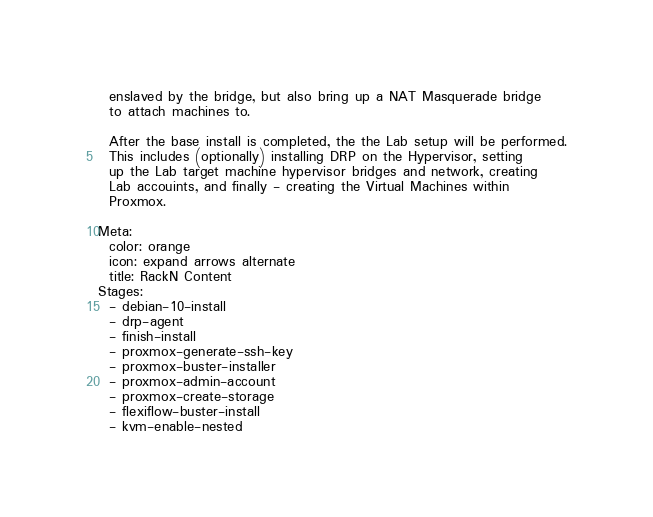<code> <loc_0><loc_0><loc_500><loc_500><_YAML_>  enslaved by the bridge, but also bring up a NAT Masquerade bridge
  to attach machines to.

  After the base install is completed, the the Lab setup will be performed.
  This includes (optionally) installing DRP on the Hypervisor, setting
  up the Lab target machine hypervisor bridges and network, creating
  Lab accouints, and finally - creating the Virtual Machines within
  Proxmox.

Meta:
  color: orange
  icon: expand arrows alternate
  title: RackN Content
Stages:
  - debian-10-install
  - drp-agent
  - finish-install
  - proxmox-generate-ssh-key
  - proxmox-buster-installer
  - proxmox-admin-account
  - proxmox-create-storage
  - flexiflow-buster-install
  - kvm-enable-nested</code> 